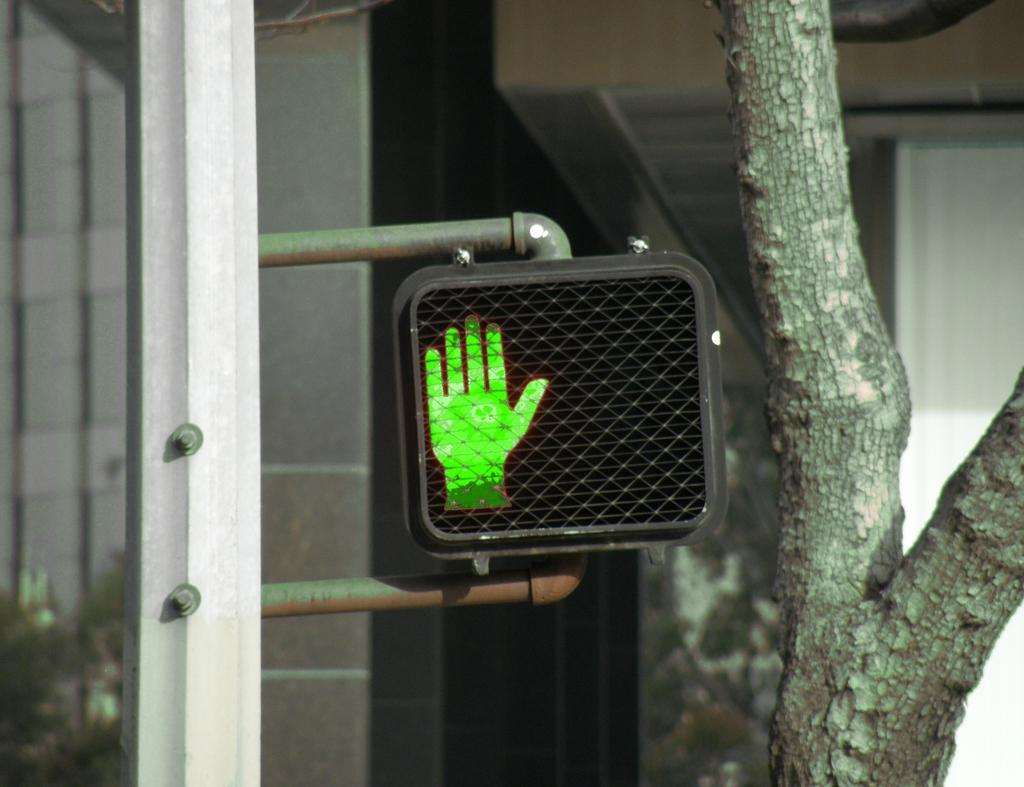Where was the image taken? The image is taken outdoors. What can be seen on the left side of the image? There is a pole with a signboard on the left side of the image. What is present on the right side of the image? There is a tree on the right side of the image. What can be seen in the background of the image? There is a wall in the background of the image. What type of tank is visible in the image? There is no tank present in the image. What level of difficulty is the girl facing in the image? There is no girl present in the image, and therefore no level of difficulty can be determined. 